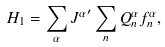<formula> <loc_0><loc_0><loc_500><loc_500>H _ { 1 } = \sum _ { \alpha } { J ^ { \alpha } } ^ { \prime } \sum _ { n } Q ^ { \alpha } _ { n } f ^ { \alpha } _ { n } ,</formula> 